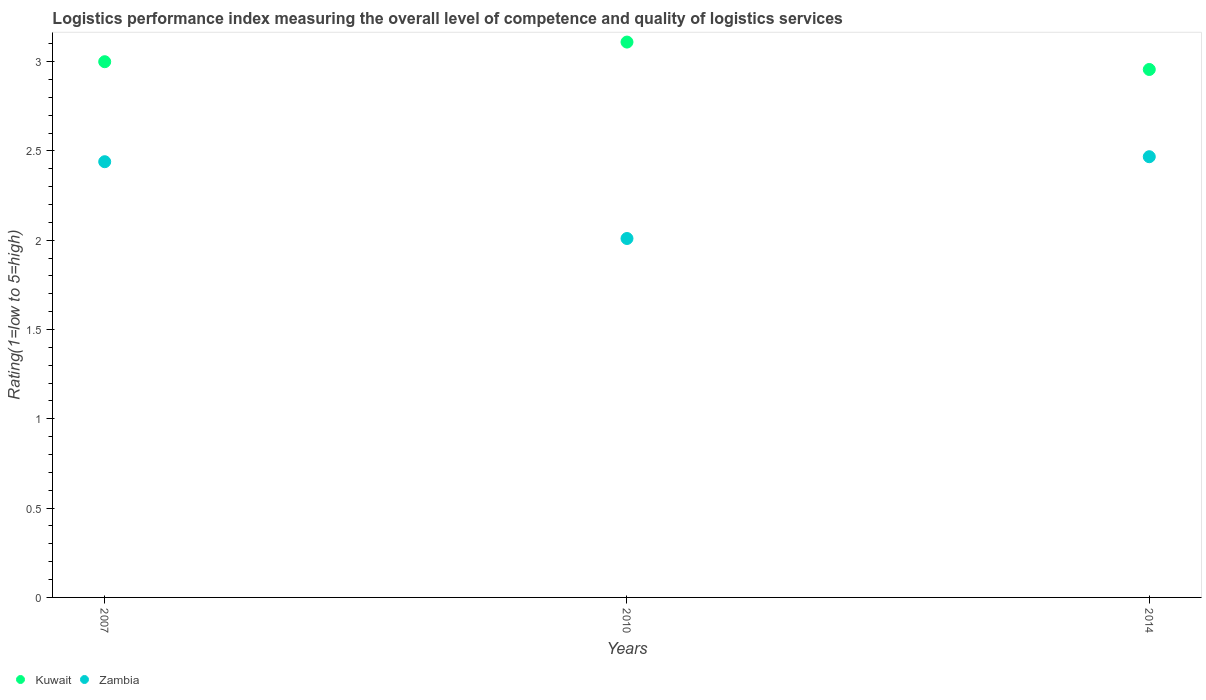Is the number of dotlines equal to the number of legend labels?
Offer a very short reply. Yes. What is the Logistic performance index in Kuwait in 2010?
Provide a short and direct response. 3.11. Across all years, what is the maximum Logistic performance index in Zambia?
Provide a short and direct response. 2.47. Across all years, what is the minimum Logistic performance index in Zambia?
Your answer should be very brief. 2.01. In which year was the Logistic performance index in Kuwait maximum?
Offer a very short reply. 2010. What is the total Logistic performance index in Zambia in the graph?
Keep it short and to the point. 6.92. What is the difference between the Logistic performance index in Kuwait in 2007 and that in 2010?
Provide a succinct answer. -0.11. What is the difference between the Logistic performance index in Zambia in 2010 and the Logistic performance index in Kuwait in 2007?
Offer a very short reply. -0.99. What is the average Logistic performance index in Zambia per year?
Your answer should be very brief. 2.31. In the year 2007, what is the difference between the Logistic performance index in Zambia and Logistic performance index in Kuwait?
Give a very brief answer. -0.56. What is the ratio of the Logistic performance index in Kuwait in 2007 to that in 2010?
Provide a succinct answer. 0.96. Is the Logistic performance index in Zambia in 2007 less than that in 2010?
Provide a short and direct response. No. What is the difference between the highest and the second highest Logistic performance index in Kuwait?
Offer a terse response. 0.11. What is the difference between the highest and the lowest Logistic performance index in Kuwait?
Offer a terse response. 0.15. Is the sum of the Logistic performance index in Kuwait in 2007 and 2014 greater than the maximum Logistic performance index in Zambia across all years?
Make the answer very short. Yes. Does the Logistic performance index in Zambia monotonically increase over the years?
Offer a terse response. No. Is the Logistic performance index in Kuwait strictly greater than the Logistic performance index in Zambia over the years?
Offer a terse response. Yes. Are the values on the major ticks of Y-axis written in scientific E-notation?
Your answer should be compact. No. Where does the legend appear in the graph?
Keep it short and to the point. Bottom left. How many legend labels are there?
Your response must be concise. 2. What is the title of the graph?
Offer a very short reply. Logistics performance index measuring the overall level of competence and quality of logistics services. What is the label or title of the Y-axis?
Provide a succinct answer. Rating(1=low to 5=high). What is the Rating(1=low to 5=high) in Zambia in 2007?
Your answer should be compact. 2.44. What is the Rating(1=low to 5=high) in Kuwait in 2010?
Give a very brief answer. 3.11. What is the Rating(1=low to 5=high) in Zambia in 2010?
Give a very brief answer. 2.01. What is the Rating(1=low to 5=high) in Kuwait in 2014?
Keep it short and to the point. 2.96. What is the Rating(1=low to 5=high) of Zambia in 2014?
Ensure brevity in your answer.  2.47. Across all years, what is the maximum Rating(1=low to 5=high) of Kuwait?
Provide a short and direct response. 3.11. Across all years, what is the maximum Rating(1=low to 5=high) in Zambia?
Ensure brevity in your answer.  2.47. Across all years, what is the minimum Rating(1=low to 5=high) in Kuwait?
Offer a very short reply. 2.96. Across all years, what is the minimum Rating(1=low to 5=high) in Zambia?
Ensure brevity in your answer.  2.01. What is the total Rating(1=low to 5=high) in Kuwait in the graph?
Provide a succinct answer. 9.07. What is the total Rating(1=low to 5=high) of Zambia in the graph?
Provide a short and direct response. 6.92. What is the difference between the Rating(1=low to 5=high) in Kuwait in 2007 and that in 2010?
Give a very brief answer. -0.11. What is the difference between the Rating(1=low to 5=high) in Zambia in 2007 and that in 2010?
Give a very brief answer. 0.43. What is the difference between the Rating(1=low to 5=high) in Kuwait in 2007 and that in 2014?
Offer a terse response. 0.04. What is the difference between the Rating(1=low to 5=high) in Zambia in 2007 and that in 2014?
Offer a very short reply. -0.03. What is the difference between the Rating(1=low to 5=high) of Kuwait in 2010 and that in 2014?
Offer a very short reply. 0.15. What is the difference between the Rating(1=low to 5=high) of Zambia in 2010 and that in 2014?
Your answer should be compact. -0.46. What is the difference between the Rating(1=low to 5=high) of Kuwait in 2007 and the Rating(1=low to 5=high) of Zambia in 2010?
Offer a terse response. 0.99. What is the difference between the Rating(1=low to 5=high) of Kuwait in 2007 and the Rating(1=low to 5=high) of Zambia in 2014?
Make the answer very short. 0.53. What is the difference between the Rating(1=low to 5=high) in Kuwait in 2010 and the Rating(1=low to 5=high) in Zambia in 2014?
Offer a terse response. 0.64. What is the average Rating(1=low to 5=high) of Kuwait per year?
Provide a succinct answer. 3.02. What is the average Rating(1=low to 5=high) in Zambia per year?
Offer a terse response. 2.31. In the year 2007, what is the difference between the Rating(1=low to 5=high) in Kuwait and Rating(1=low to 5=high) in Zambia?
Give a very brief answer. 0.56. In the year 2014, what is the difference between the Rating(1=low to 5=high) in Kuwait and Rating(1=low to 5=high) in Zambia?
Provide a succinct answer. 0.49. What is the ratio of the Rating(1=low to 5=high) in Kuwait in 2007 to that in 2010?
Ensure brevity in your answer.  0.96. What is the ratio of the Rating(1=low to 5=high) in Zambia in 2007 to that in 2010?
Your answer should be very brief. 1.21. What is the ratio of the Rating(1=low to 5=high) of Kuwait in 2007 to that in 2014?
Offer a very short reply. 1.01. What is the ratio of the Rating(1=low to 5=high) in Zambia in 2007 to that in 2014?
Make the answer very short. 0.99. What is the ratio of the Rating(1=low to 5=high) of Kuwait in 2010 to that in 2014?
Your answer should be compact. 1.05. What is the ratio of the Rating(1=low to 5=high) in Zambia in 2010 to that in 2014?
Your response must be concise. 0.81. What is the difference between the highest and the second highest Rating(1=low to 5=high) of Kuwait?
Your answer should be compact. 0.11. What is the difference between the highest and the second highest Rating(1=low to 5=high) of Zambia?
Your answer should be compact. 0.03. What is the difference between the highest and the lowest Rating(1=low to 5=high) in Kuwait?
Your answer should be compact. 0.15. What is the difference between the highest and the lowest Rating(1=low to 5=high) of Zambia?
Give a very brief answer. 0.46. 